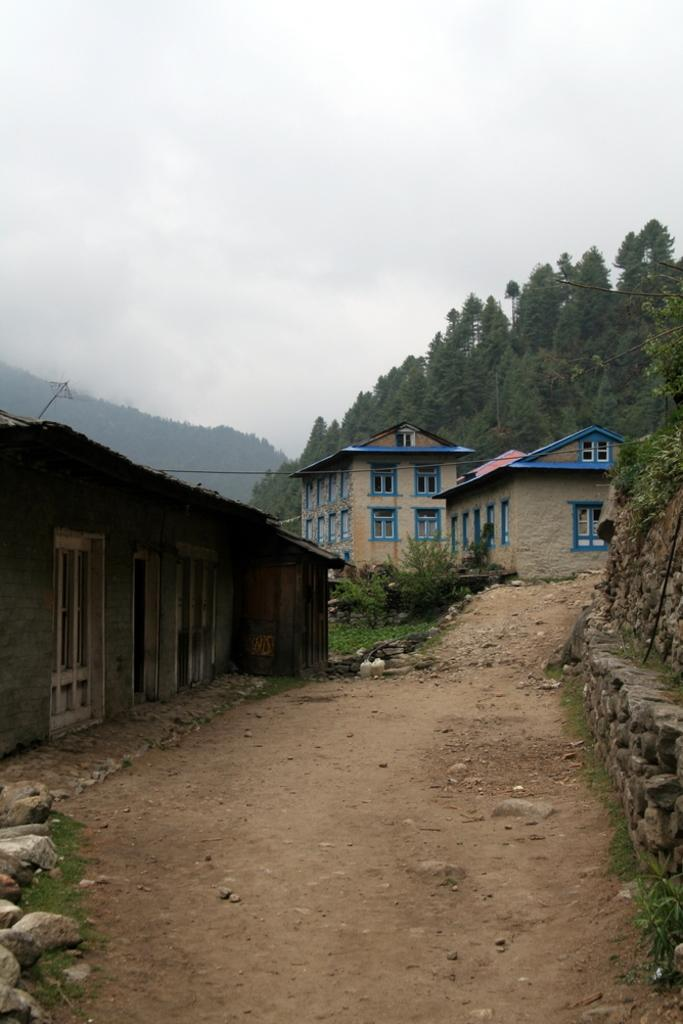How many houses can be seen in the image? There are three houses in the image. What is located on the right side of the image? There is a wall on the right side of the image. What type of vegetation is visible in the image? There are trees visible in the image. What part of the natural environment is visible in the image? The sky is visible in the image. What type of ground surface is visible at the bottom of the image? There are stones visible at the bottom of the image. What type of jewel is hanging from the tree in the image? There is no jewel hanging from the tree in the image; only trees are visible. What type of cloth is draped over the wall in the image? There is no cloth draped over the wall in the image; only a wall is visible. 